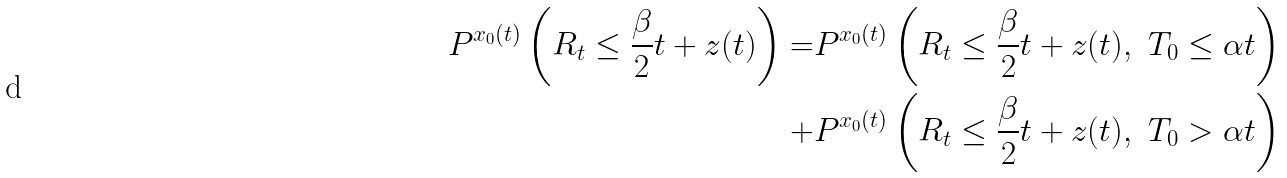Convert formula to latex. <formula><loc_0><loc_0><loc_500><loc_500>P ^ { x _ { 0 } ( t ) } \left ( R _ { t } \leq \frac { \beta } { 2 } t + z ( t ) \right ) = & P ^ { x _ { 0 } ( t ) } \left ( R _ { t } \leq \frac { \beta } { 2 } t + z ( t ) , \ T _ { 0 } \leq \alpha t \right ) \\ + & P ^ { x _ { 0 } ( t ) } \left ( R _ { t } \leq \frac { \beta } { 2 } t + z ( t ) , \ T _ { 0 } > \alpha t \right )</formula> 